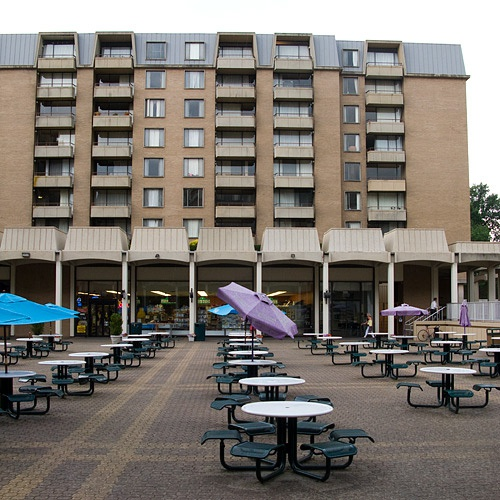Describe the objects in this image and their specific colors. I can see chair in white, black, gray, and lightgray tones, dining table in white, black, gray, darkgray, and lightgray tones, dining table in white, black, lightgray, gray, and darkgray tones, umbrella in white, darkgray, and purple tones, and chair in white, black, blue, purple, and darkblue tones in this image. 